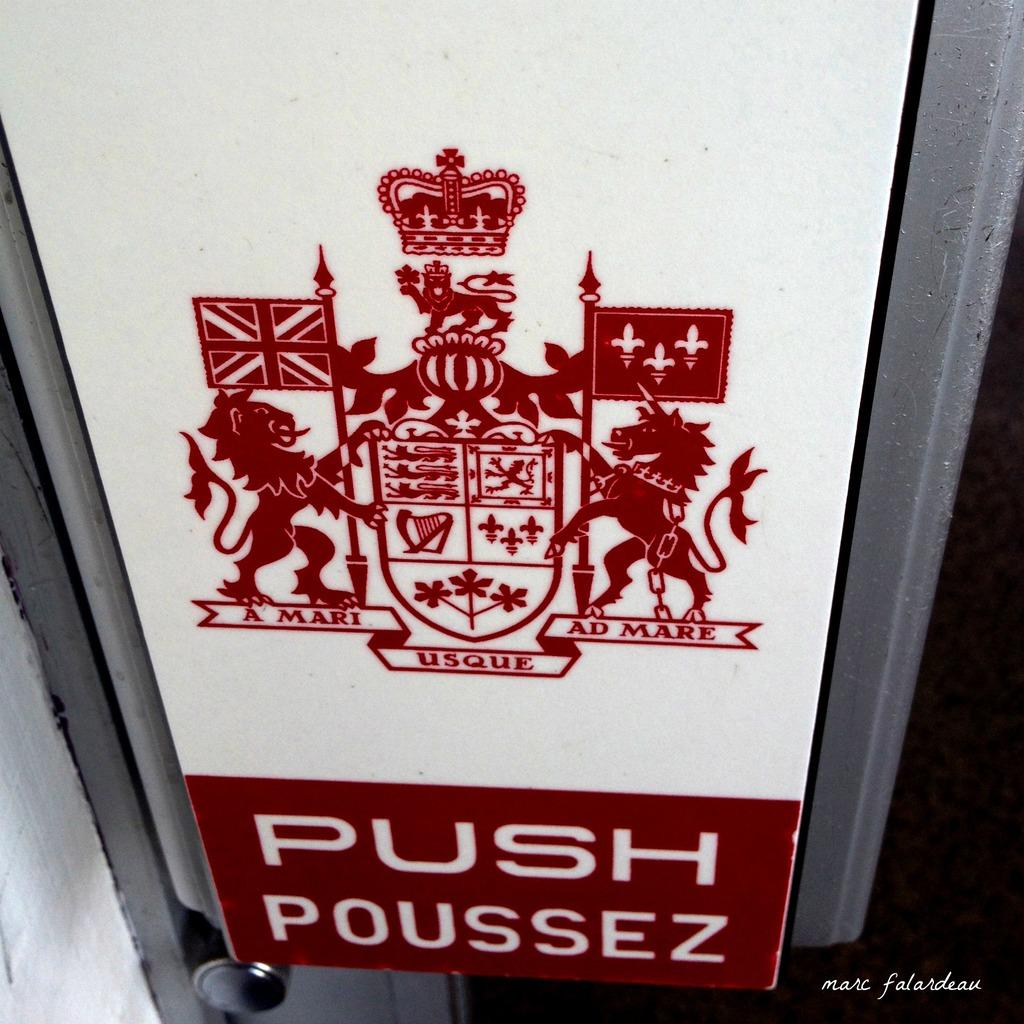<image>
Create a compact narrative representing the image presented. A detailed crest has the words A Mari, Usque, and Ad Mare written underneath it in red. 